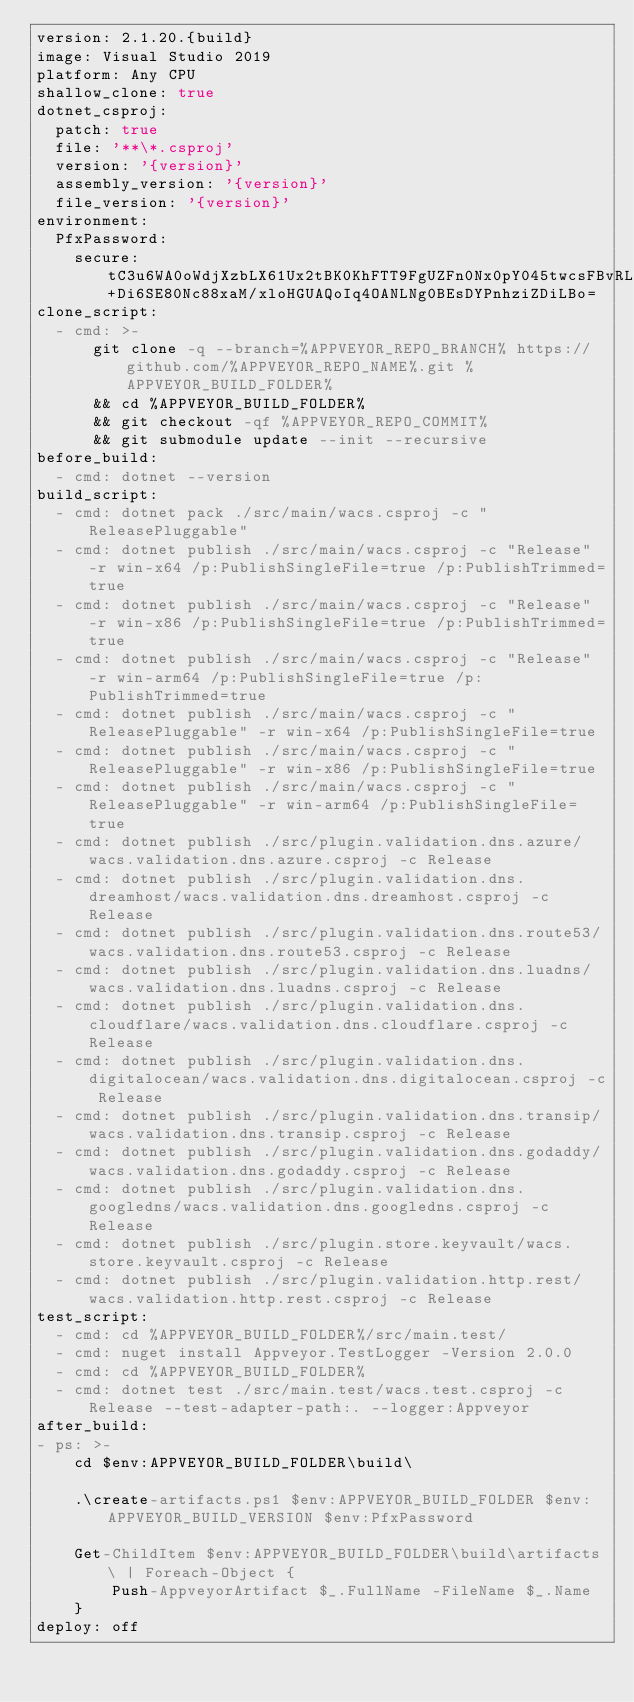Convert code to text. <code><loc_0><loc_0><loc_500><loc_500><_YAML_>version: 2.1.20.{build}
image: Visual Studio 2019
platform: Any CPU
shallow_clone: true
dotnet_csproj:
  patch: true
  file: '**\*.csproj'
  version: '{version}'
  assembly_version: '{version}'
  file_version: '{version}'
environment:
  PfxPassword:
    secure: tC3u6WA0oWdjXzbLX61Ux2tBK0KhFTT9FgUZFn0Nx0pY045twcsFBvRL+Di6SE80Nc88xaM/xloHGUAQoIq4OANLNg0BEsDYPnhziZDiLBo=
clone_script:
  - cmd: >-
      git clone -q --branch=%APPVEYOR_REPO_BRANCH% https://github.com/%APPVEYOR_REPO_NAME%.git %APPVEYOR_BUILD_FOLDER%
      && cd %APPVEYOR_BUILD_FOLDER%
      && git checkout -qf %APPVEYOR_REPO_COMMIT%
      && git submodule update --init --recursive
before_build:
  - cmd: dotnet --version
build_script:
  - cmd: dotnet pack ./src/main/wacs.csproj -c "ReleasePluggable"
  - cmd: dotnet publish ./src/main/wacs.csproj -c "Release" -r win-x64 /p:PublishSingleFile=true /p:PublishTrimmed=true
  - cmd: dotnet publish ./src/main/wacs.csproj -c "Release" -r win-x86 /p:PublishSingleFile=true /p:PublishTrimmed=true
  - cmd: dotnet publish ./src/main/wacs.csproj -c "Release" -r win-arm64 /p:PublishSingleFile=true /p:PublishTrimmed=true
  - cmd: dotnet publish ./src/main/wacs.csproj -c "ReleasePluggable" -r win-x64 /p:PublishSingleFile=true
  - cmd: dotnet publish ./src/main/wacs.csproj -c "ReleasePluggable" -r win-x86 /p:PublishSingleFile=true
  - cmd: dotnet publish ./src/main/wacs.csproj -c "ReleasePluggable" -r win-arm64 /p:PublishSingleFile=true
  - cmd: dotnet publish ./src/plugin.validation.dns.azure/wacs.validation.dns.azure.csproj -c Release
  - cmd: dotnet publish ./src/plugin.validation.dns.dreamhost/wacs.validation.dns.dreamhost.csproj -c Release
  - cmd: dotnet publish ./src/plugin.validation.dns.route53/wacs.validation.dns.route53.csproj -c Release
  - cmd: dotnet publish ./src/plugin.validation.dns.luadns/wacs.validation.dns.luadns.csproj -c Release
  - cmd: dotnet publish ./src/plugin.validation.dns.cloudflare/wacs.validation.dns.cloudflare.csproj -c Release
  - cmd: dotnet publish ./src/plugin.validation.dns.digitalocean/wacs.validation.dns.digitalocean.csproj -c Release
  - cmd: dotnet publish ./src/plugin.validation.dns.transip/wacs.validation.dns.transip.csproj -c Release
  - cmd: dotnet publish ./src/plugin.validation.dns.godaddy/wacs.validation.dns.godaddy.csproj -c Release
  - cmd: dotnet publish ./src/plugin.validation.dns.googledns/wacs.validation.dns.googledns.csproj -c Release
  - cmd: dotnet publish ./src/plugin.store.keyvault/wacs.store.keyvault.csproj -c Release
  - cmd: dotnet publish ./src/plugin.validation.http.rest/wacs.validation.http.rest.csproj -c Release
test_script:
  - cmd: cd %APPVEYOR_BUILD_FOLDER%/src/main.test/
  - cmd: nuget install Appveyor.TestLogger -Version 2.0.0
  - cmd: cd %APPVEYOR_BUILD_FOLDER%
  - cmd: dotnet test ./src/main.test/wacs.test.csproj -c Release --test-adapter-path:. --logger:Appveyor 
after_build:
- ps: >-
    cd $env:APPVEYOR_BUILD_FOLDER\build\

    .\create-artifacts.ps1 $env:APPVEYOR_BUILD_FOLDER $env:APPVEYOR_BUILD_VERSION $env:PfxPassword

    Get-ChildItem $env:APPVEYOR_BUILD_FOLDER\build\artifacts\ | Foreach-Object {
        Push-AppveyorArtifact $_.FullName -FileName $_.Name
    }
deploy: off
</code> 